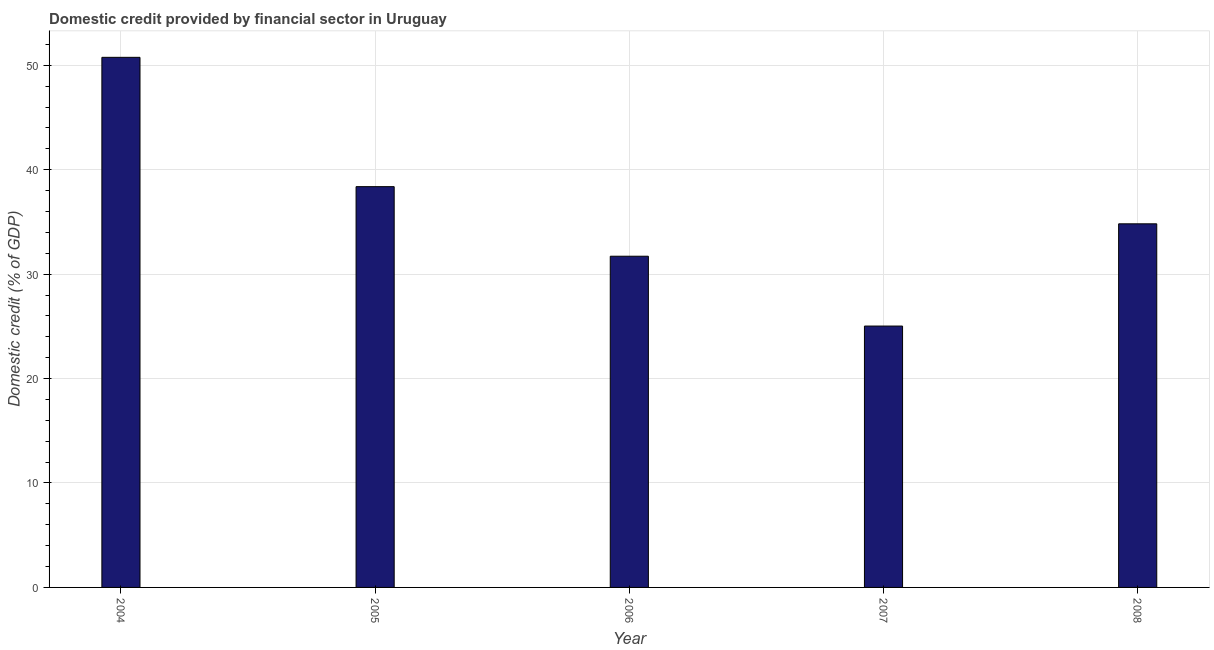Does the graph contain any zero values?
Provide a succinct answer. No. What is the title of the graph?
Make the answer very short. Domestic credit provided by financial sector in Uruguay. What is the label or title of the X-axis?
Provide a short and direct response. Year. What is the label or title of the Y-axis?
Provide a succinct answer. Domestic credit (% of GDP). What is the domestic credit provided by financial sector in 2004?
Your answer should be very brief. 50.76. Across all years, what is the maximum domestic credit provided by financial sector?
Make the answer very short. 50.76. Across all years, what is the minimum domestic credit provided by financial sector?
Offer a very short reply. 25.03. In which year was the domestic credit provided by financial sector minimum?
Give a very brief answer. 2007. What is the sum of the domestic credit provided by financial sector?
Offer a very short reply. 180.7. What is the difference between the domestic credit provided by financial sector in 2004 and 2008?
Ensure brevity in your answer.  15.94. What is the average domestic credit provided by financial sector per year?
Offer a terse response. 36.14. What is the median domestic credit provided by financial sector?
Offer a very short reply. 34.82. What is the ratio of the domestic credit provided by financial sector in 2006 to that in 2007?
Keep it short and to the point. 1.27. Is the difference between the domestic credit provided by financial sector in 2005 and 2007 greater than the difference between any two years?
Your answer should be compact. No. What is the difference between the highest and the second highest domestic credit provided by financial sector?
Your response must be concise. 12.38. What is the difference between the highest and the lowest domestic credit provided by financial sector?
Your response must be concise. 25.73. How many bars are there?
Your answer should be compact. 5. Are all the bars in the graph horizontal?
Offer a very short reply. No. How many years are there in the graph?
Make the answer very short. 5. What is the difference between two consecutive major ticks on the Y-axis?
Make the answer very short. 10. What is the Domestic credit (% of GDP) of 2004?
Offer a very short reply. 50.76. What is the Domestic credit (% of GDP) of 2005?
Provide a short and direct response. 38.38. What is the Domestic credit (% of GDP) in 2006?
Give a very brief answer. 31.71. What is the Domestic credit (% of GDP) in 2007?
Provide a short and direct response. 25.03. What is the Domestic credit (% of GDP) of 2008?
Provide a succinct answer. 34.82. What is the difference between the Domestic credit (% of GDP) in 2004 and 2005?
Provide a short and direct response. 12.38. What is the difference between the Domestic credit (% of GDP) in 2004 and 2006?
Make the answer very short. 19.05. What is the difference between the Domestic credit (% of GDP) in 2004 and 2007?
Your answer should be compact. 25.73. What is the difference between the Domestic credit (% of GDP) in 2004 and 2008?
Give a very brief answer. 15.94. What is the difference between the Domestic credit (% of GDP) in 2005 and 2006?
Keep it short and to the point. 6.66. What is the difference between the Domestic credit (% of GDP) in 2005 and 2007?
Your answer should be compact. 13.35. What is the difference between the Domestic credit (% of GDP) in 2005 and 2008?
Give a very brief answer. 3.56. What is the difference between the Domestic credit (% of GDP) in 2006 and 2007?
Offer a very short reply. 6.69. What is the difference between the Domestic credit (% of GDP) in 2006 and 2008?
Your answer should be compact. -3.1. What is the difference between the Domestic credit (% of GDP) in 2007 and 2008?
Your response must be concise. -9.79. What is the ratio of the Domestic credit (% of GDP) in 2004 to that in 2005?
Make the answer very short. 1.32. What is the ratio of the Domestic credit (% of GDP) in 2004 to that in 2006?
Offer a very short reply. 1.6. What is the ratio of the Domestic credit (% of GDP) in 2004 to that in 2007?
Give a very brief answer. 2.03. What is the ratio of the Domestic credit (% of GDP) in 2004 to that in 2008?
Keep it short and to the point. 1.46. What is the ratio of the Domestic credit (% of GDP) in 2005 to that in 2006?
Make the answer very short. 1.21. What is the ratio of the Domestic credit (% of GDP) in 2005 to that in 2007?
Offer a terse response. 1.53. What is the ratio of the Domestic credit (% of GDP) in 2005 to that in 2008?
Provide a short and direct response. 1.1. What is the ratio of the Domestic credit (% of GDP) in 2006 to that in 2007?
Keep it short and to the point. 1.27. What is the ratio of the Domestic credit (% of GDP) in 2006 to that in 2008?
Provide a succinct answer. 0.91. What is the ratio of the Domestic credit (% of GDP) in 2007 to that in 2008?
Keep it short and to the point. 0.72. 